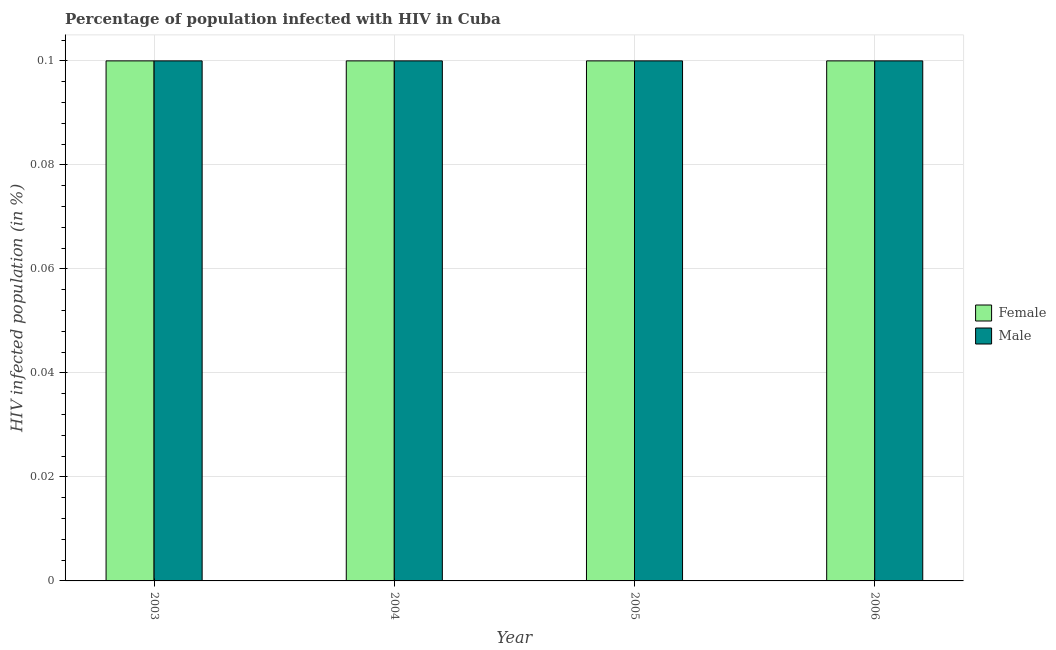How many different coloured bars are there?
Offer a terse response. 2. How many bars are there on the 1st tick from the left?
Provide a succinct answer. 2. How many bars are there on the 1st tick from the right?
Provide a succinct answer. 2. What is the label of the 2nd group of bars from the left?
Provide a succinct answer. 2004. Across all years, what is the minimum percentage of females who are infected with hiv?
Provide a short and direct response. 0.1. In which year was the percentage of females who are infected with hiv maximum?
Ensure brevity in your answer.  2003. In which year was the percentage of females who are infected with hiv minimum?
Keep it short and to the point. 2003. What is the difference between the percentage of males who are infected with hiv in 2003 and that in 2006?
Your answer should be compact. 0. What is the difference between the percentage of females who are infected with hiv in 2003 and the percentage of males who are infected with hiv in 2004?
Your answer should be compact. 0. In the year 2006, what is the difference between the percentage of females who are infected with hiv and percentage of males who are infected with hiv?
Offer a very short reply. 0. In how many years, is the percentage of females who are infected with hiv greater than 0.092 %?
Your answer should be compact. 4. What is the ratio of the percentage of males who are infected with hiv in 2004 to that in 2006?
Your answer should be very brief. 1. Is the percentage of males who are infected with hiv in 2003 less than that in 2004?
Give a very brief answer. No. What is the difference between the highest and the second highest percentage of females who are infected with hiv?
Provide a short and direct response. 0. In how many years, is the percentage of females who are infected with hiv greater than the average percentage of females who are infected with hiv taken over all years?
Your response must be concise. 0. Is the sum of the percentage of males who are infected with hiv in 2003 and 2005 greater than the maximum percentage of females who are infected with hiv across all years?
Your response must be concise. Yes. What does the 2nd bar from the left in 2004 represents?
Give a very brief answer. Male. How many years are there in the graph?
Your answer should be compact. 4. Are the values on the major ticks of Y-axis written in scientific E-notation?
Keep it short and to the point. No. Does the graph contain any zero values?
Provide a short and direct response. No. Where does the legend appear in the graph?
Offer a terse response. Center right. What is the title of the graph?
Ensure brevity in your answer.  Percentage of population infected with HIV in Cuba. Does "% of GNI" appear as one of the legend labels in the graph?
Offer a terse response. No. What is the label or title of the Y-axis?
Your answer should be very brief. HIV infected population (in %). What is the HIV infected population (in %) in Female in 2003?
Your answer should be compact. 0.1. What is the HIV infected population (in %) in Female in 2004?
Make the answer very short. 0.1. What is the HIV infected population (in %) in Male in 2004?
Offer a terse response. 0.1. What is the HIV infected population (in %) in Male in 2006?
Provide a succinct answer. 0.1. Across all years, what is the maximum HIV infected population (in %) in Male?
Offer a terse response. 0.1. What is the difference between the HIV infected population (in %) of Female in 2003 and that in 2004?
Ensure brevity in your answer.  0. What is the difference between the HIV infected population (in %) in Female in 2003 and that in 2006?
Make the answer very short. 0. What is the difference between the HIV infected population (in %) of Male in 2003 and that in 2006?
Offer a terse response. 0. What is the difference between the HIV infected population (in %) of Male in 2004 and that in 2005?
Offer a terse response. 0. What is the difference between the HIV infected population (in %) of Female in 2004 and that in 2006?
Give a very brief answer. 0. What is the difference between the HIV infected population (in %) in Male in 2005 and that in 2006?
Offer a terse response. 0. What is the difference between the HIV infected population (in %) of Female in 2003 and the HIV infected population (in %) of Male in 2004?
Ensure brevity in your answer.  0. What is the difference between the HIV infected population (in %) of Female in 2004 and the HIV infected population (in %) of Male in 2005?
Provide a succinct answer. 0. What is the average HIV infected population (in %) of Male per year?
Provide a short and direct response. 0.1. In the year 2003, what is the difference between the HIV infected population (in %) of Female and HIV infected population (in %) of Male?
Your answer should be compact. 0. In the year 2004, what is the difference between the HIV infected population (in %) in Female and HIV infected population (in %) in Male?
Offer a terse response. 0. In the year 2005, what is the difference between the HIV infected population (in %) of Female and HIV infected population (in %) of Male?
Your answer should be very brief. 0. In the year 2006, what is the difference between the HIV infected population (in %) in Female and HIV infected population (in %) in Male?
Keep it short and to the point. 0. What is the ratio of the HIV infected population (in %) in Male in 2003 to that in 2005?
Provide a succinct answer. 1. What is the ratio of the HIV infected population (in %) in Male in 2003 to that in 2006?
Provide a short and direct response. 1. What is the ratio of the HIV infected population (in %) of Female in 2004 to that in 2005?
Provide a short and direct response. 1. What is the ratio of the HIV infected population (in %) of Female in 2004 to that in 2006?
Your answer should be very brief. 1. What is the ratio of the HIV infected population (in %) of Male in 2004 to that in 2006?
Your response must be concise. 1. What is the ratio of the HIV infected population (in %) of Female in 2005 to that in 2006?
Ensure brevity in your answer.  1. What is the ratio of the HIV infected population (in %) in Male in 2005 to that in 2006?
Your answer should be compact. 1. What is the difference between the highest and the second highest HIV infected population (in %) of Female?
Ensure brevity in your answer.  0. What is the difference between the highest and the lowest HIV infected population (in %) of Female?
Make the answer very short. 0. 